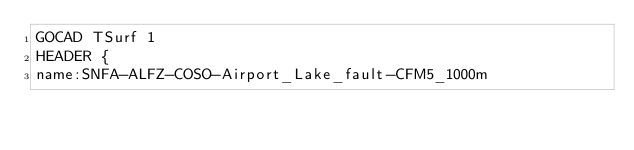Convert code to text. <code><loc_0><loc_0><loc_500><loc_500><_TypeScript_>GOCAD TSurf 1
HEADER {
name:SNFA-ALFZ-COSO-Airport_Lake_fault-CFM5_1000m</code> 